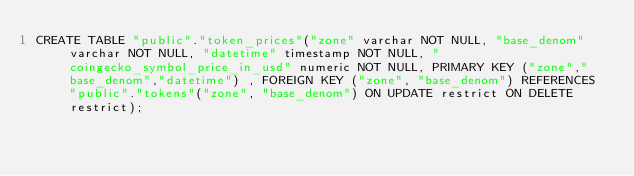<code> <loc_0><loc_0><loc_500><loc_500><_SQL_>CREATE TABLE "public"."token_prices"("zone" varchar NOT NULL, "base_denom" varchar NOT NULL, "datetime" timestamp NOT NULL, "coingecko_symbol_price_in_usd" numeric NOT NULL, PRIMARY KEY ("zone","base_denom","datetime") , FOREIGN KEY ("zone", "base_denom") REFERENCES "public"."tokens"("zone", "base_denom") ON UPDATE restrict ON DELETE restrict);
</code> 